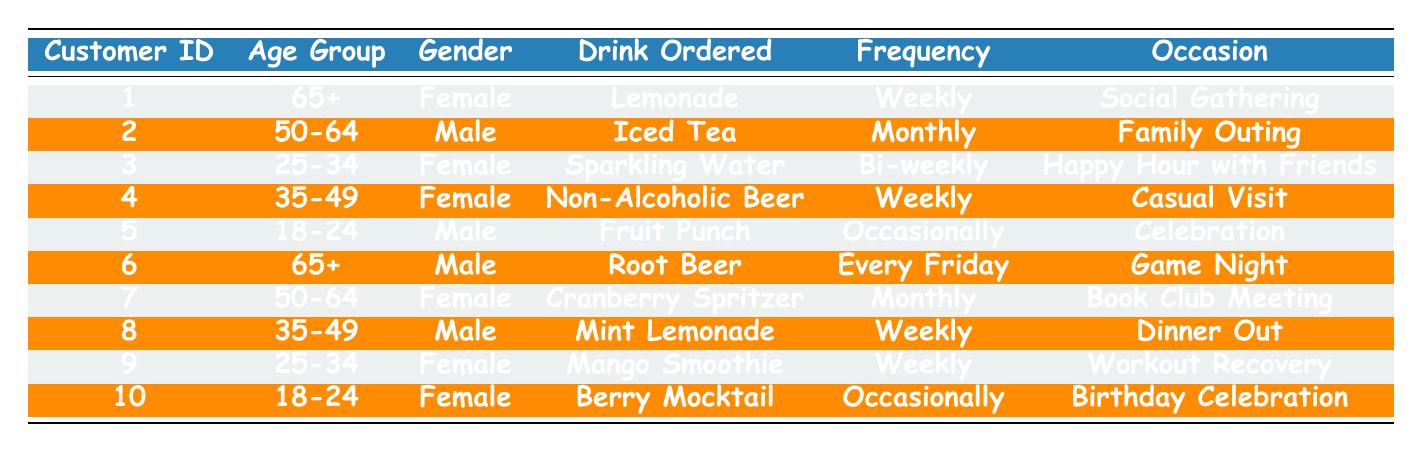What drink do the customers over 65 years old prefer? There are two customers over 65 years old: Customer 1 who ordered Lemonade and Customer 6 who ordered Root Beer. Thus, the drinks they prefer are Lemonade and Root Beer.
Answer: Lemonade and Root Beer How many customers ordered drinks weekly? The customers who ordered drinks weekly are Customer 1 (Lemonade), Customer 4 (Non-Alcoholic Beer), Customer 6 (Root Beer), Customer 8 (Mint Lemonade), and Customer 9 (Mango Smoothie). Counting these gives a total of 5 customers.
Answer: 5 Which gender ordered more non-alcoholic drinks? By examining the table, there are 6 female customers (1, 3, 4, 7, 9, 10) and 4 male customers (2, 5, 6, 8). Since there are more female customers, the answer is female.
Answer: Female What is the frequency of orders for the drink Mango Smoothie? Looking at Customer 9 in the table, the order frequency for Mango Smoothie is weekly.
Answer: Weekly Are there any customers who ordered more than one drink? Each customer in the table is listed only once with their ordered drink. Therefore, no customers ordered more than one drink.
Answer: No How many customers in the age group 35-49 ordered drinks? There are two customers in the 35-49 age group: Customer 4 (Non-Alcoholic Beer) and Customer 8 (Mint Lemonade). Counting these yields 2 customers.
Answer: 2 What proportion of non-alcoholic drink orders comes from females? There are 6 female customers and a total of 10 customers. The proportion can be calculated as 6 out of 10, or 6/10, which simplifies to 0.6.
Answer: 0.6 Which drink is ordered occasionally by customers? According to the table, the drinks ordered occasionally are Fruit Punch by Customer 5 and Berry Mocktail by Customer 10.
Answer: Fruit Punch and Berry Mocktail How often do customers aged 50-64 order drinks? The table shows that Customer 2 orders Iced Tea monthly and Customer 7 orders Cranberry Spritzer monthly as well. Therefore, customers in this age group order monthly.
Answer: Monthly What is the favorite drink for social gatherings among the customers? Customer 1 ordered Lemonade for a social gathering. Hence, Lemonade is the favorite drink for social gatherings among the customers.
Answer: Lemonade 